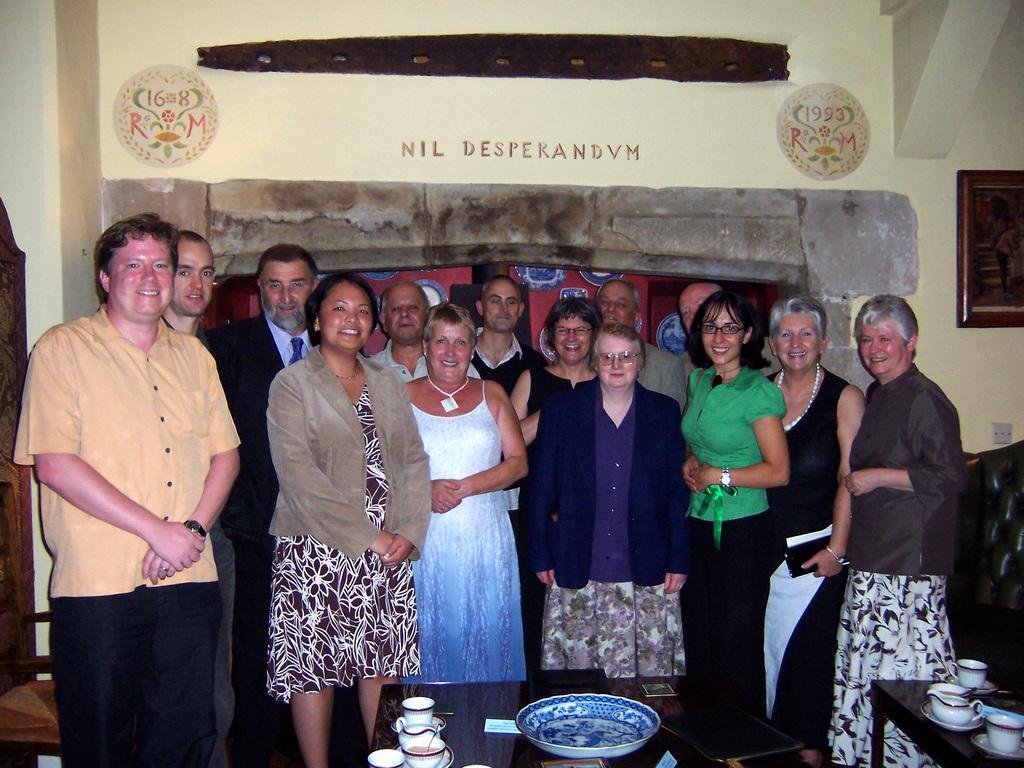Could you give a brief overview of what you see in this image? In this picture there are group of people standing. There is a plate and there are cups, saucers and objects on the tables. At the back there might be plates on the wall and there is text on the wall. On the right side of the image there is a frame on the wall and there is a chair. On the left side of the image there is a chair. 